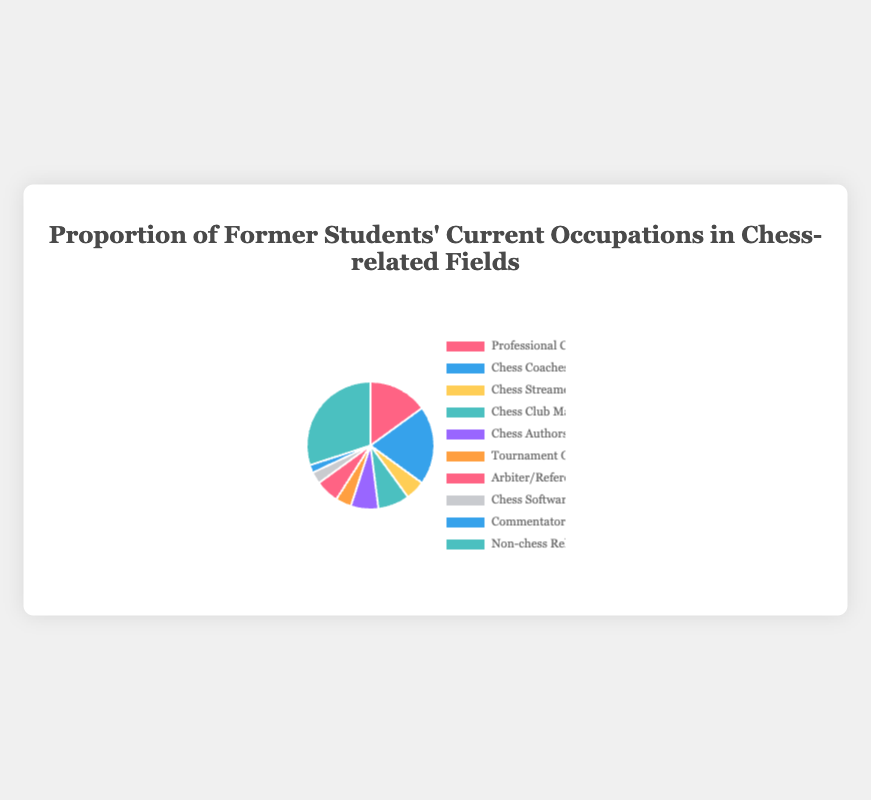Which occupation has the highest proportion of former students? The pie chart shows that the 'Non-chess Related Occupations' slice is the largest. Therefore, this segment indicates the highest proportion.
Answer: Non-chess Related Occupations What is the total percentage of former students in occupations directly related to chess? Adding the percentages of all chess-related occupations: Professional Chess Players (15%), Chess Coaches (20%), Chess Streamers (5%), Chess Club Managers (8%), Chess Authors (7%), Tournament Organizers (4%), Arbiter/Referee (6%), Chess Software Developers (3%), Commentators/Analysts (2%) results in 70% total.
Answer: 70% How does the proportion of chess coaches compare to the proportion of chess authors? The pie chart indicates that Chess Coaches have a larger slice (20%) compared to Chess Authors (7%). Thus, the proportion of Chess Coaches is higher.
Answer: Chess Coaches are higher What is the combined proportion of former students who are Tournament Organizers and Arbiter/Referee? According to the pie chart, Tournament Organizers represent 4% and Arbiter/Referee represent 6%. Adding these percentages provides a combined proportion of 10%.
Answer: 10% Which occupation category has the lowest proportion of former students? The smallest slice in the pie chart belongs to Commentators/Analysts, which indicates the lowest proportion at 2%.
Answer: Commentators/Analysts Are there more former students who are chess software developers or chess streamers? The pie chart shows the slice for Chess Streamers (5%) is larger than that for Chess Software Developers (3%), meaning there are more Chess Streamers.
Answer: Chess Streamers What is the difference between the percentages of former students who are Professional Chess Players and Non-chess Related Occupations? The pie chart shows Professional Chess Players at 15% and Non-chess Related Occupations at 30%. The difference is 30% - 15% = 15%.
Answer: 15% What proportion of former students are involved in club management or coaching? Adding the percentages of Chess Club Managers (8%) and Chess Coaches (20%) gives us 28%.
Answer: 28% How many chess-related career categories are represented in the pie chart? Counting all chess-related categories (Professional Chess Players, Chess Coaches, Chess Streamers, Chess Club Managers, Chess Authors, Tournament Organizers, Arbiter/Referee, Chess Software Developers, Commentators/Analysts) results in nine categories.
Answer: 9 